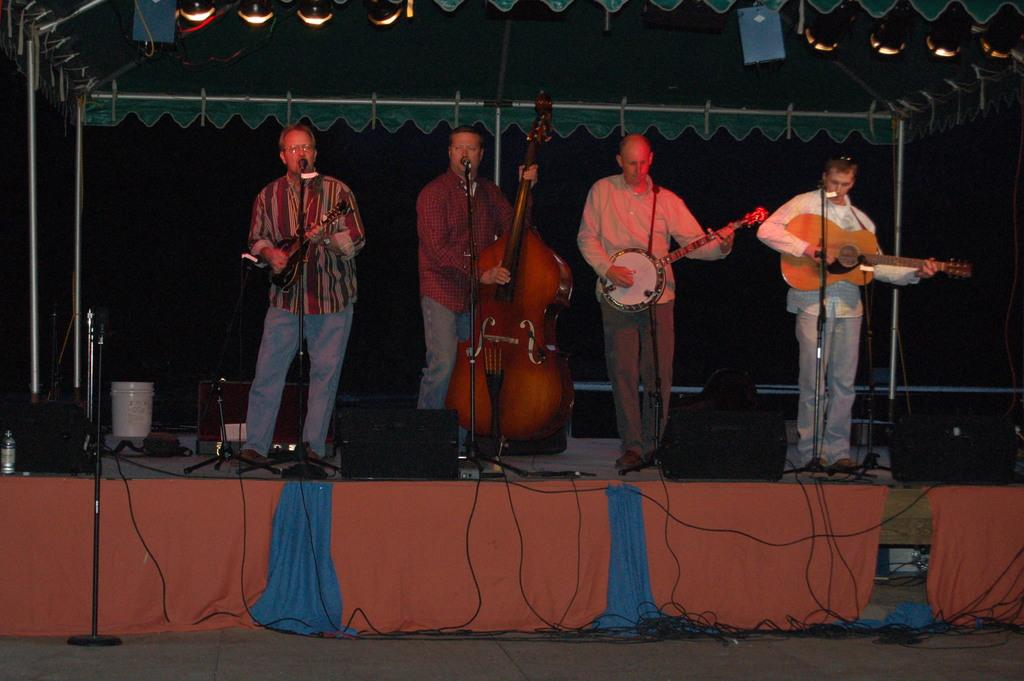How many people are in the image? There are four persons in the image. What are the four persons doing in the image? The four persons are performing a musical show. What are the instruments being used by the performers? Each person is holding an instrument, such as a guitar. What is the color of the stage in the image? The stage is orange in color. How does the digestion process of the audience members affect the performance in the image? The image does not provide information about the audience members' digestion process, so it cannot be determined how it affects the performance. 